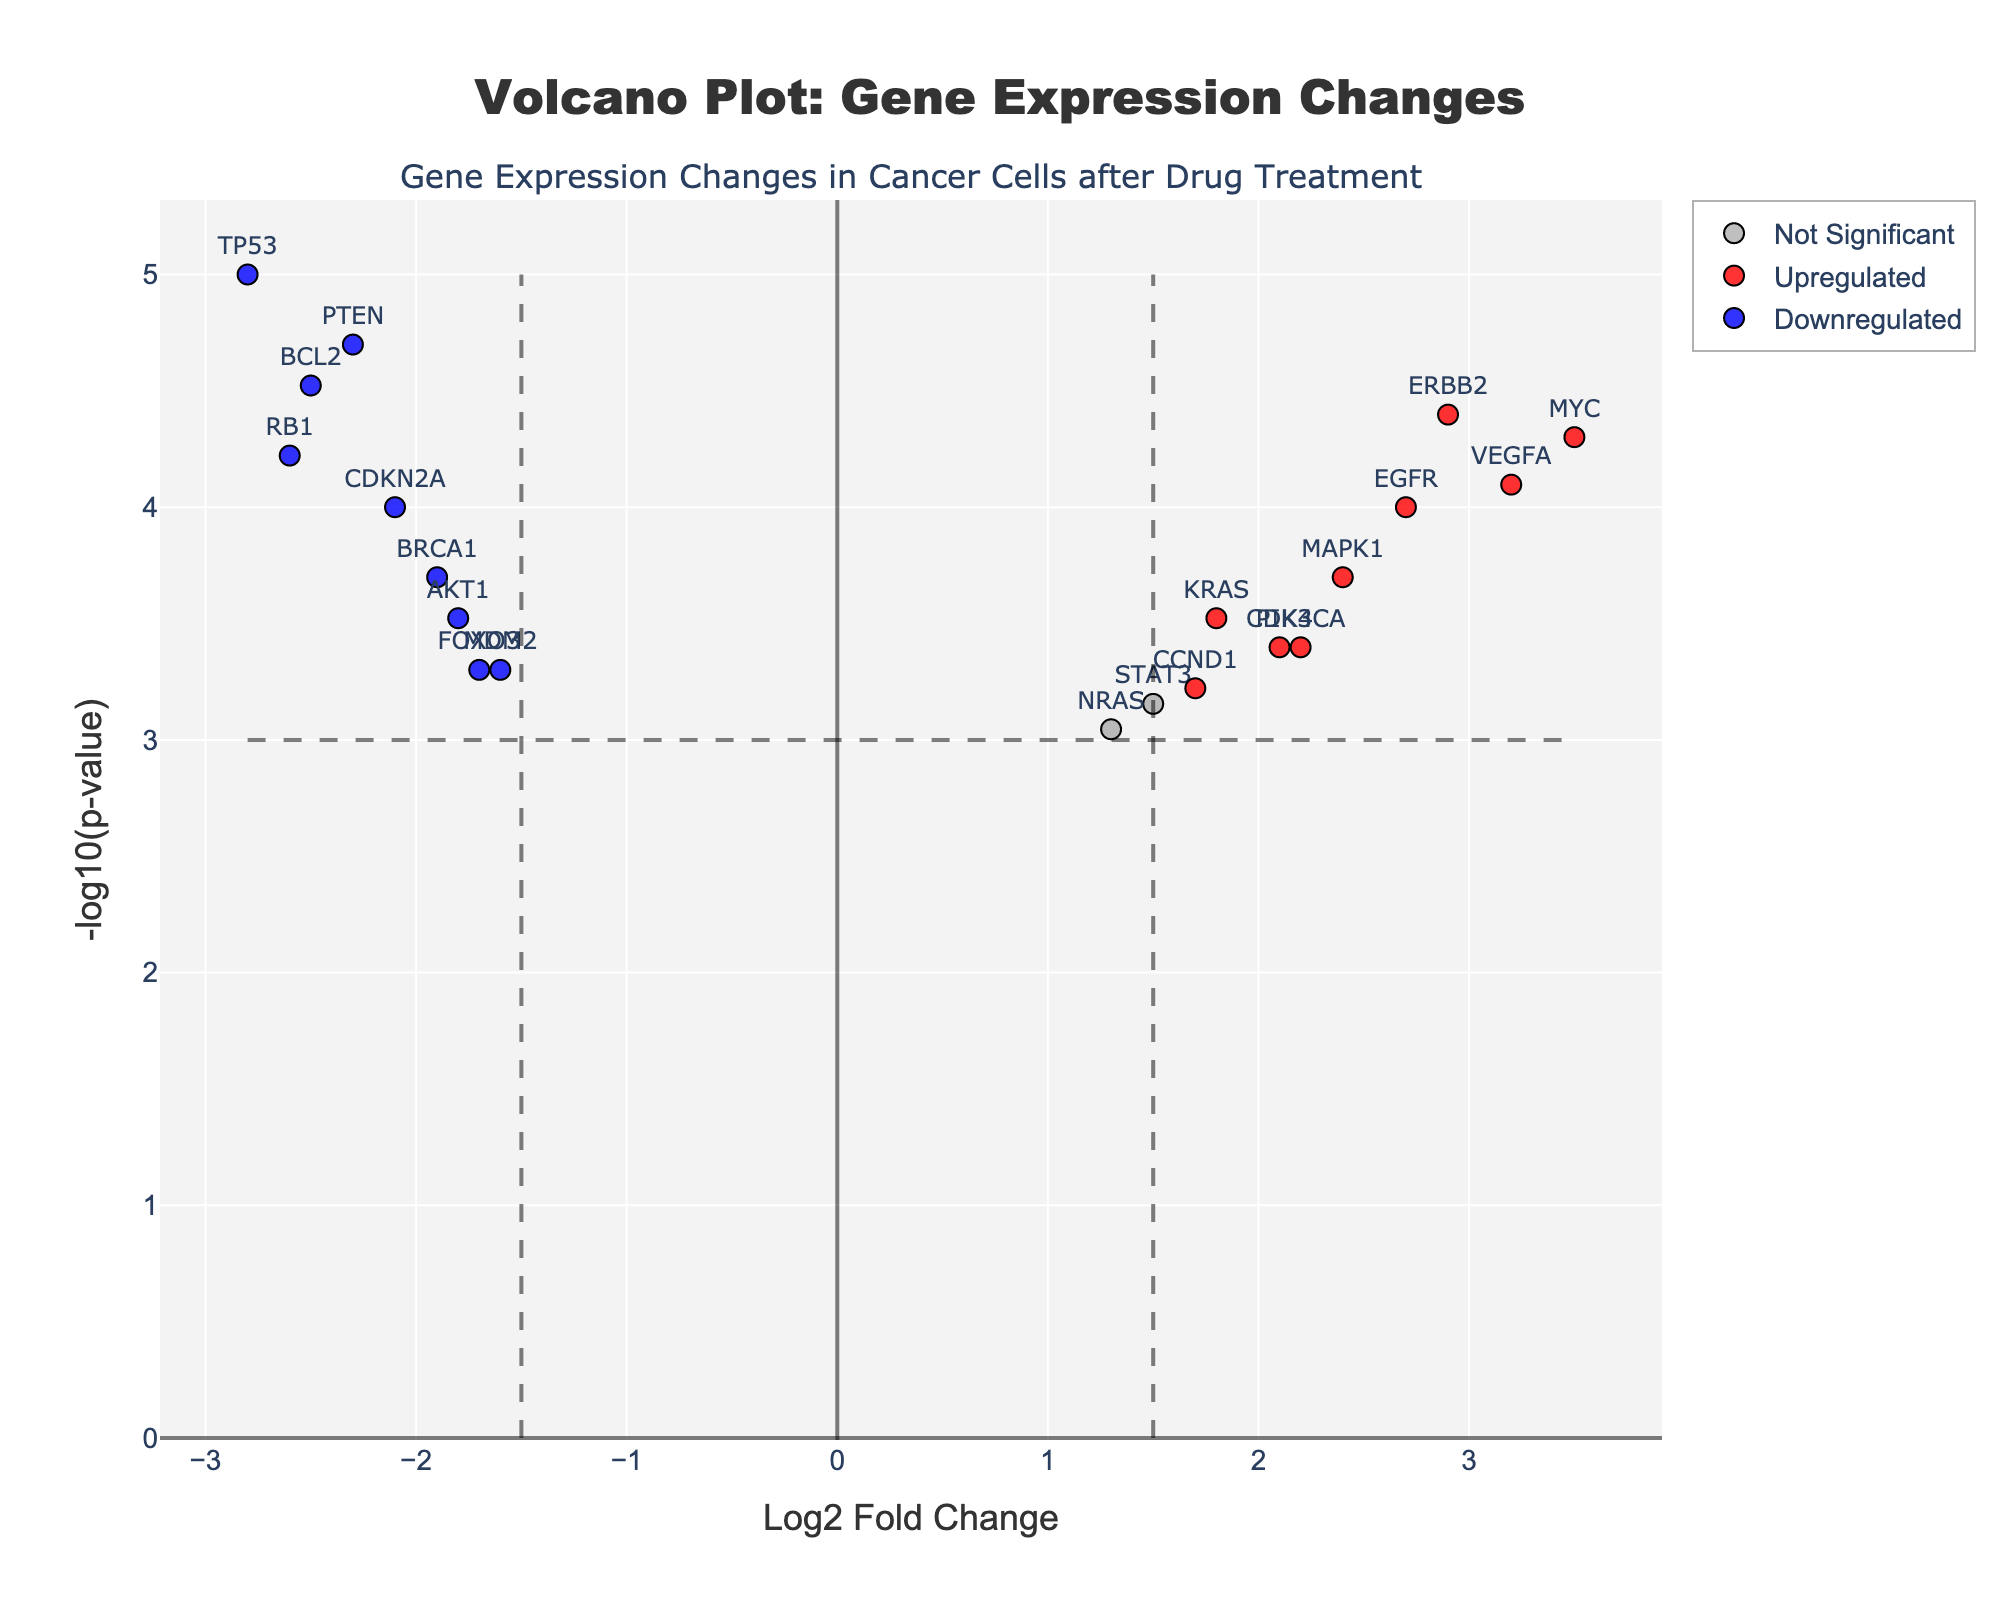What is the title of the figure? The title of a plot is usually located at the top center. In this case, it reads 'Volcano Plot: Gene Expression Changes'.
Answer: Volcano Plot: Gene Expression Changes How is the y-axis labeled? The y-axis label, found vertically along the y-axis, describes the values plotted there. It reads '-log10(p-value)'.
Answer: -log10(p-value) How many genes are classified as upregulated? To count the number of upregulated genes, look for points colored in red. There are 5 such points: MYC, EGFR, VEGFA, ERBB2, and PIK3CA.
Answer: 5 Which gene has the highest -log10(p-value)? The gene with the highest -log10(p-value) will be the one furthest up the y-axis. TP53 is the highest.
Answer: TP53 How many genes are downregulated and significant? To find this, count the number of blue points (downregulated) that are above the horizontal threshold line that represents the p-value threshold. There are 6 genes: TP53, BRCA1, PTEN, MDM2, BCL2, and RB1.
Answer: 6 What is the log2 fold change of MYC? Locate the point labeled MYC. It is positioned at a Log2FoldChange of 3.5 on the x-axis.
Answer: 3.5 Which gene is more significantly upregulated: VEGFA or ERBB2? Both genes are upregulated (red points), but compare their -log10(p-value) on the y-axis. ERBB2 is higher on the y-axis.
Answer: ERBB2 On which side of the plot (left or right) are the downregulated genes located? Downregulated genes have negative log2 fold changes and are therefore located on the left side of the plot.
Answer: Left What color represents the genes classified as 'Not Significant'? The category 'Not Significant' is represented by gray points in the plot.
Answer: Gray Which axes represent log fold change and p-value in the plot, respectively? The log fold change is represented by the x-axis, and the p-value (-log10 transformation) is represented by the y-axis.
Answer: x-axis: log fold change, y-axis: p-value 